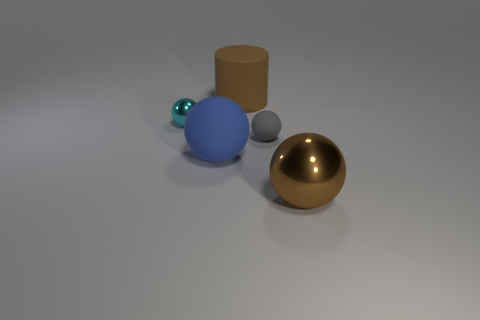Subtract all brown spheres. How many spheres are left? 3 Subtract all cyan balls. How many balls are left? 3 Subtract 1 cylinders. How many cylinders are left? 0 Subtract all spheres. How many objects are left? 1 Subtract all red balls. How many purple cylinders are left? 0 Subtract all tiny yellow matte cubes. Subtract all matte things. How many objects are left? 2 Add 4 cyan metallic things. How many cyan metallic things are left? 5 Add 5 matte things. How many matte things exist? 8 Add 1 tiny blue metallic balls. How many objects exist? 6 Subtract 1 brown cylinders. How many objects are left? 4 